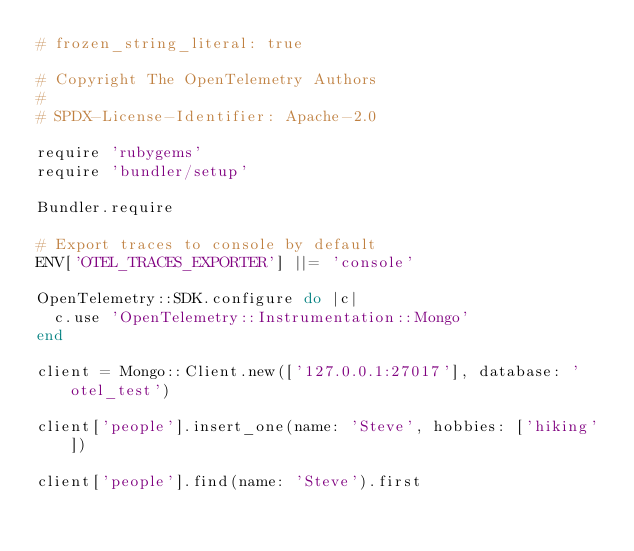Convert code to text. <code><loc_0><loc_0><loc_500><loc_500><_Ruby_># frozen_string_literal: true

# Copyright The OpenTelemetry Authors
#
# SPDX-License-Identifier: Apache-2.0

require 'rubygems'
require 'bundler/setup'

Bundler.require

# Export traces to console by default
ENV['OTEL_TRACES_EXPORTER'] ||= 'console'

OpenTelemetry::SDK.configure do |c|
  c.use 'OpenTelemetry::Instrumentation::Mongo'
end

client = Mongo::Client.new(['127.0.0.1:27017'], database: 'otel_test')

client['people'].insert_one(name: 'Steve', hobbies: ['hiking'])

client['people'].find(name: 'Steve').first
</code> 